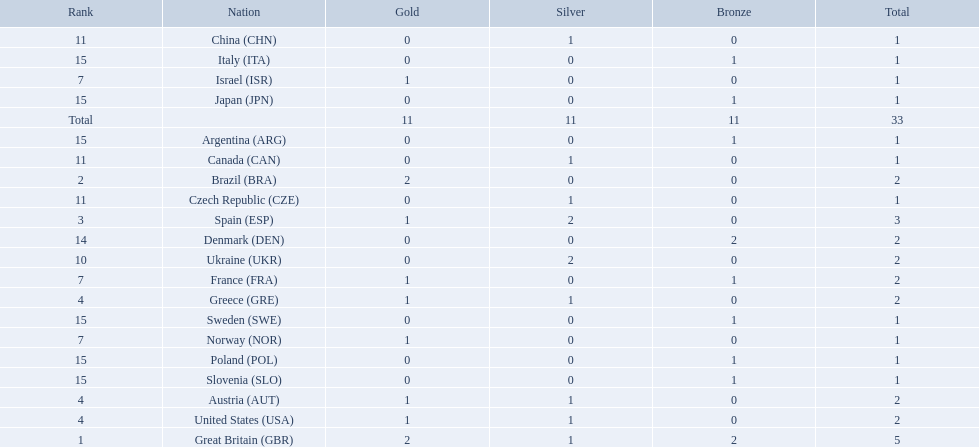How many medals did each country receive? 5, 2, 3, 2, 2, 2, 2, 1, 1, 2, 1, 1, 1, 2, 1, 1, 1, 1, 1, 1. Which country received 3 medals? Spain (ESP). 